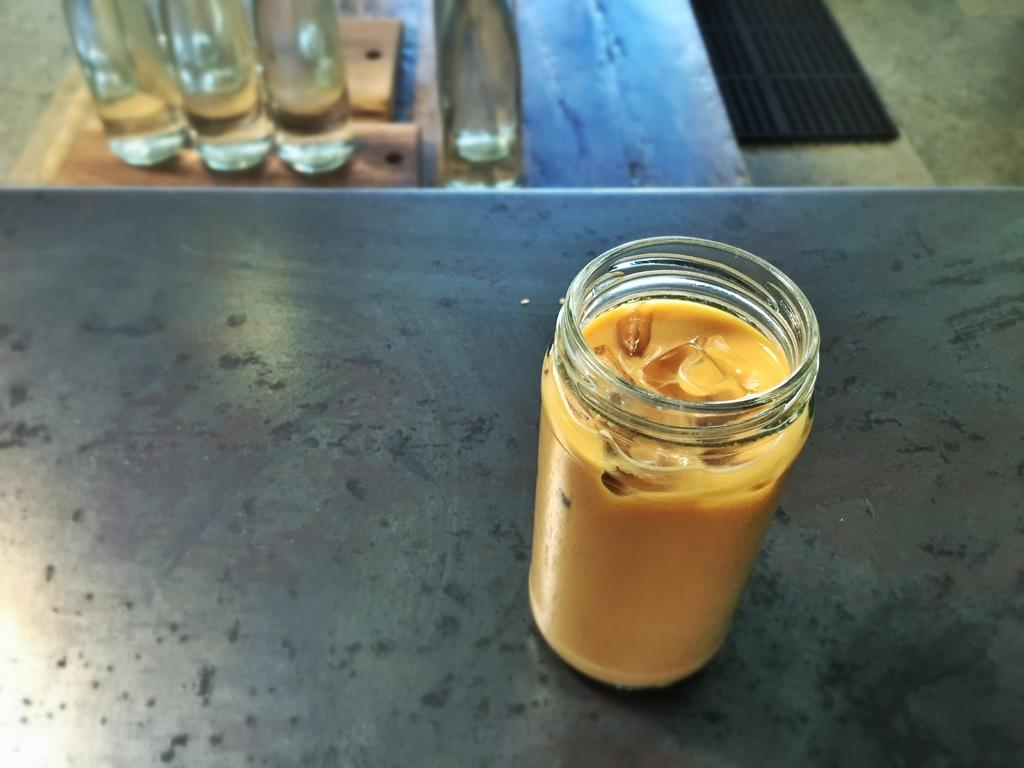What is in the glass that is visible in the image? The glass contains a yellow liquid. What else can be seen in the image besides the glass? There are bottles visible on a wooden surface in the image. What advice does the grandmother give about the power of the yellow liquid in the image? There is no grandmother or advice present in the image; it only shows a glass with a yellow liquid and bottles on a wooden surface. 